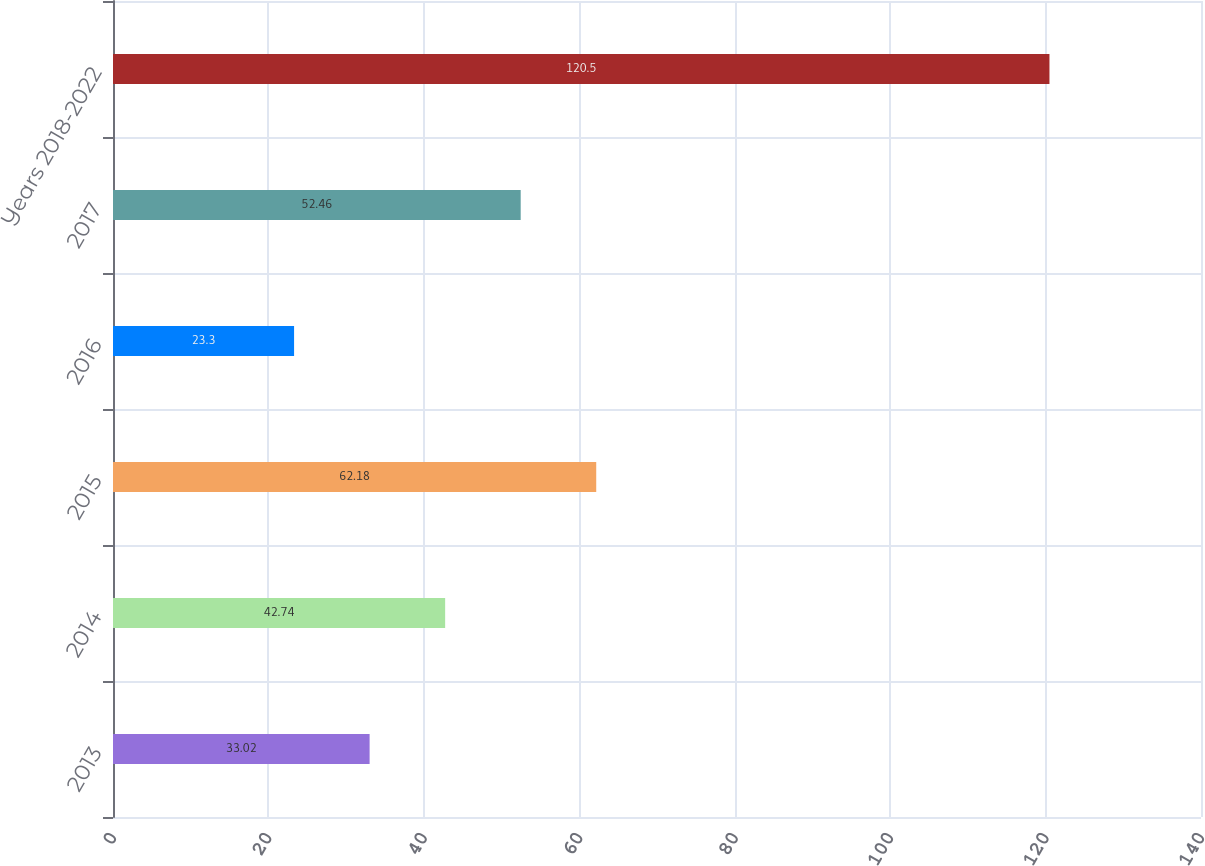Convert chart to OTSL. <chart><loc_0><loc_0><loc_500><loc_500><bar_chart><fcel>2013<fcel>2014<fcel>2015<fcel>2016<fcel>2017<fcel>Years 2018-2022<nl><fcel>33.02<fcel>42.74<fcel>62.18<fcel>23.3<fcel>52.46<fcel>120.5<nl></chart> 